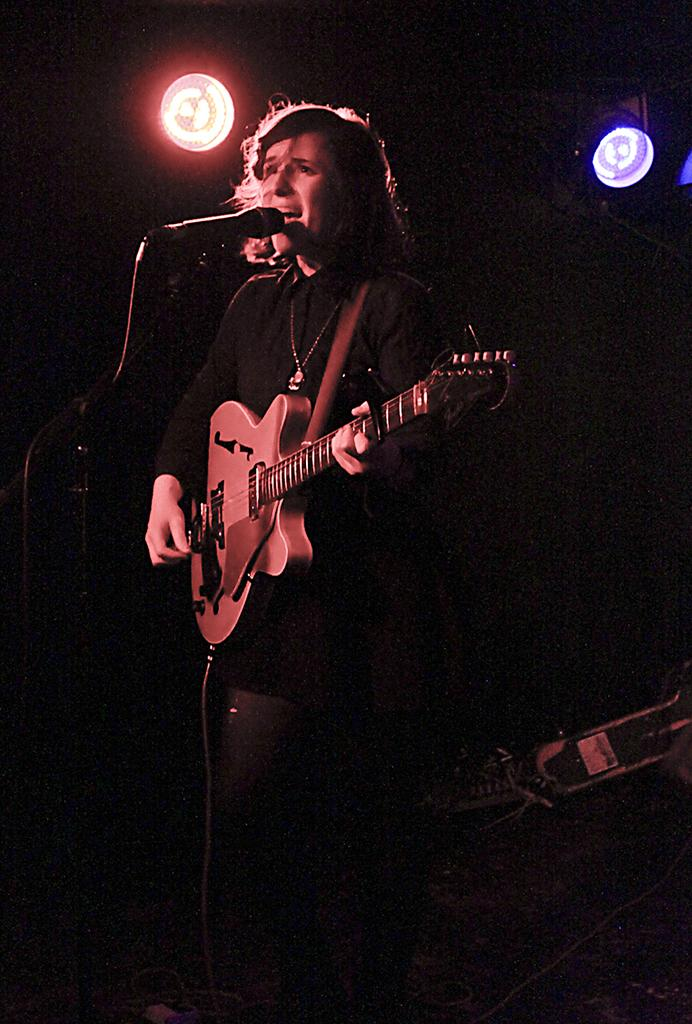Who is present in the image? There is a person in the image. What is the person holding in the image? The person is holding a guitar. What is the person standing in front of in the image? The person is standing in front of a mic. What can be seen in the background of the image? There are lights visible in the background of the image. Where is the sofa located in the image? There is no sofa present in the image. What type of poison is being used by the person in the image? There is no poison present in the image; the person is holding a guitar and standing in front of a mic. 